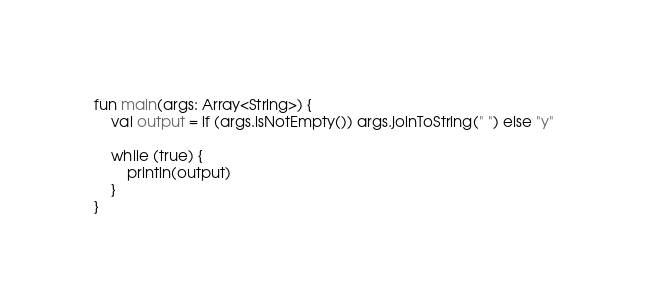<code> <loc_0><loc_0><loc_500><loc_500><_Kotlin_>fun main(args: Array<String>) {
    val output = if (args.isNotEmpty()) args.joinToString(" ") else "y"

    while (true) {
        println(output)
    }
}
</code> 